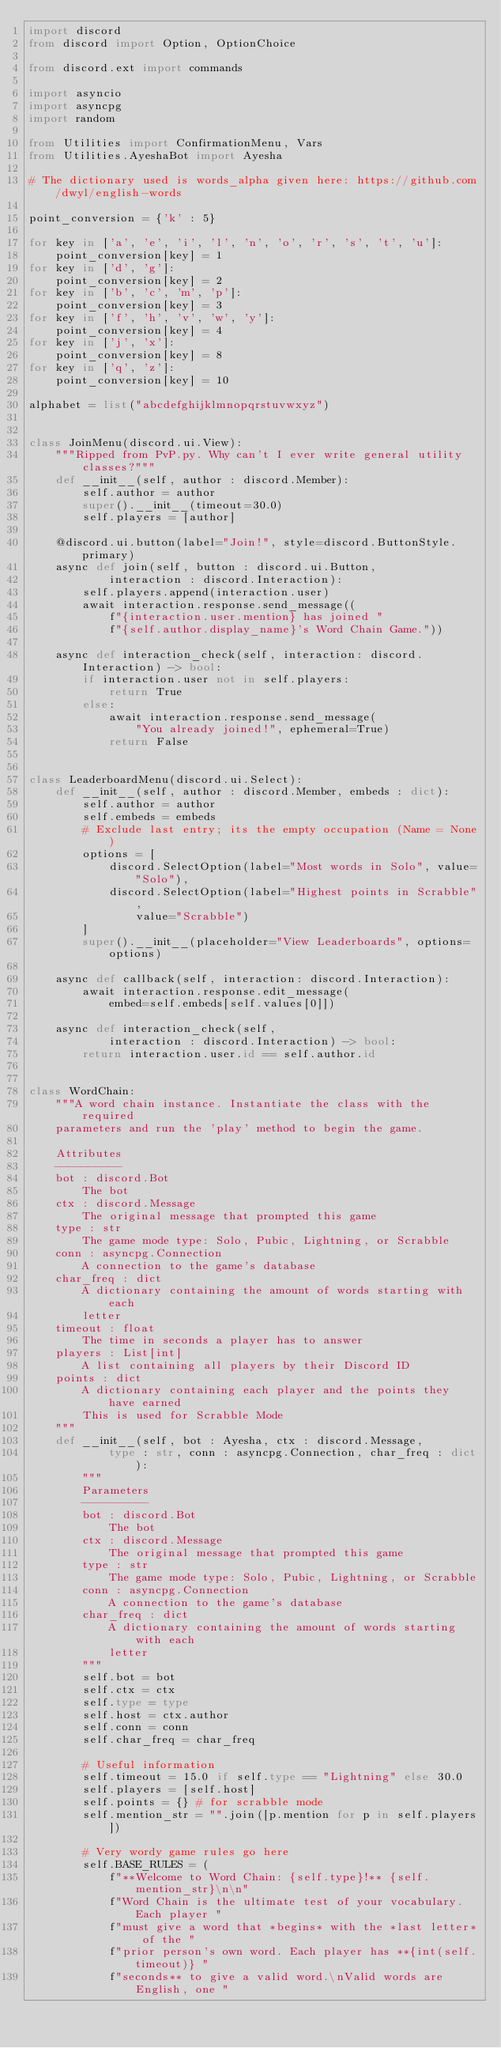Convert code to text. <code><loc_0><loc_0><loc_500><loc_500><_Python_>import discord
from discord import Option, OptionChoice

from discord.ext import commands

import asyncio
import asyncpg
import random

from Utilities import ConfirmationMenu, Vars
from Utilities.AyeshaBot import Ayesha

# The dictionary used is words_alpha given here: https://github.com/dwyl/english-words

point_conversion = {'k' : 5}

for key in ['a', 'e', 'i', 'l', 'n', 'o', 'r', 's', 't', 'u']:
    point_conversion[key] = 1
for key in ['d', 'g']:
    point_conversion[key] = 2
for key in ['b', 'c', 'm', 'p']:
    point_conversion[key] = 3
for key in ['f', 'h', 'v', 'w', 'y']:
    point_conversion[key] = 4
for key in ['j', 'x']:
    point_conversion[key] = 8
for key in ['q', 'z']:
    point_conversion[key] = 10

alphabet = list("abcdefghijklmnopqrstuvwxyz")


class JoinMenu(discord.ui.View):
    """Ripped from PvP.py. Why can't I ever write general utility classes?"""
    def __init__(self, author : discord.Member):
        self.author = author
        super().__init__(timeout=30.0)
        self.players = [author]

    @discord.ui.button(label="Join!", style=discord.ButtonStyle.primary)
    async def join(self, button : discord.ui.Button,
            interaction : discord.Interaction):
        self.players.append(interaction.user)
        await interaction.response.send_message((
            f"{interaction.user.mention} has joined "
            f"{self.author.display_name}'s Word Chain Game."))

    async def interaction_check(self, interaction: discord.Interaction) -> bool:
        if interaction.user not in self.players:
            return True
        else:
            await interaction.response.send_message(
                "You already joined!", ephemeral=True)
            return False


class LeaderboardMenu(discord.ui.Select):
    def __init__(self, author : discord.Member, embeds : dict):
        self.author = author
        self.embeds = embeds
        # Exclude last entry; its the empty occupation (Name = None)
        options = [
            discord.SelectOption(label="Most words in Solo", value="Solo"),
            discord.SelectOption(label="Highest points in Scrabble", 
                value="Scrabble")
        ]
        super().__init__(placeholder="View Leaderboards", options=options)

    async def callback(self, interaction: discord.Interaction):
        await interaction.response.edit_message(
            embed=self.embeds[self.values[0]])

    async def interaction_check(self, 
            interaction : discord.Interaction) -> bool:
        return interaction.user.id == self.author.id


class WordChain:
    """A word chain instance. Instantiate the class with the required 
    parameters and run the 'play' method to begin the game.

    Attributes
    ----------
    bot : discord.Bot 
        The bot
    ctx : discord.Message
        The original message that prompted this game
    type : str
        The game mode type: Solo, Pubic, Lightning, or Scrabble
    conn : asyncpg.Connection
        A connection to the game's database
    char_freq : dict
        A dictionary containing the amount of words starting with each
        letter
    timeout : float
        The time in seconds a player has to answer
    players : List[int]
        A list containing all players by their Discord ID
    points : dict
        A dictionary containing each player and the points they have earned
        This is used for Scrabble Mode
    """
    def __init__(self, bot : Ayesha, ctx : discord.Message,
            type : str, conn : asyncpg.Connection, char_freq : dict):
        """
        Parameters
        ----------
        bot : discord.Bot 
            The bot
        ctx : discord.Message
            The original message that prompted this game
        type : str
            The game mode type: Solo, Pubic, Lightning, or Scrabble
        conn : asyncpg.Connection
            A connection to the game's database
        char_freq : dict
            A dictionary containing the amount of words starting with each
            letter
        """
        self.bot = bot
        self.ctx = ctx
        self.type = type
        self.host = ctx.author
        self.conn = conn
        self.char_freq = char_freq

        # Useful information 
        self.timeout = 15.0 if self.type == "Lightning" else 30.0
        self.players = [self.host]
        self.points = {} # for scrabble mode
        self.mention_str = "".join([p.mention for p in self.players])

        # Very wordy game rules go here
        self.BASE_RULES = (
            f"**Welcome to Word Chain: {self.type}!** {self.mention_str}\n\n"
            f"Word Chain is the ultimate test of your vocabulary. Each player "
            f"must give a word that *begins* with the *last letter* of the "
            f"prior person's own word. Each player has **{int(self.timeout)} "
            f"seconds** to give a valid word.\nValid words are English, one "</code> 